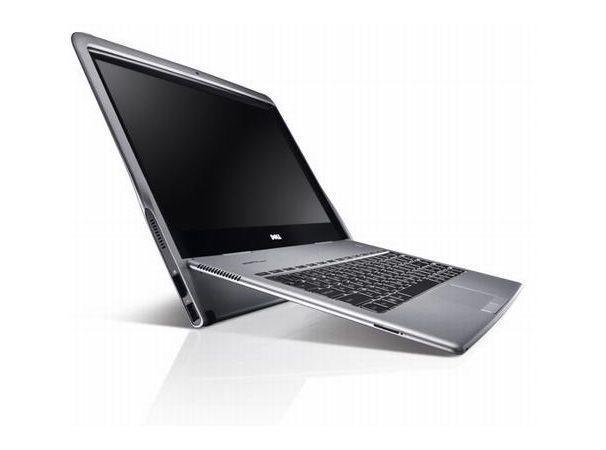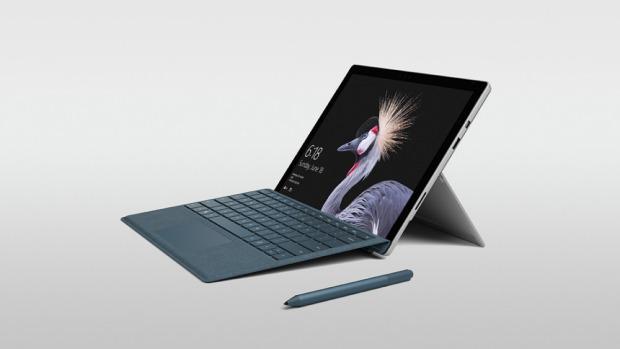The first image is the image on the left, the second image is the image on the right. Analyze the images presented: Is the assertion "In at least one image there is a silver bottomed laptop with a detachable mouse to the right." valid? Answer yes or no. No. The first image is the image on the left, the second image is the image on the right. Considering the images on both sides, is "One image shows an open laptop with its keyboard base attached and sitting flat, and the other image includes at least one screen propped up like an easel with a keyboard in front of it that does not appear to be attached." valid? Answer yes or no. No. 